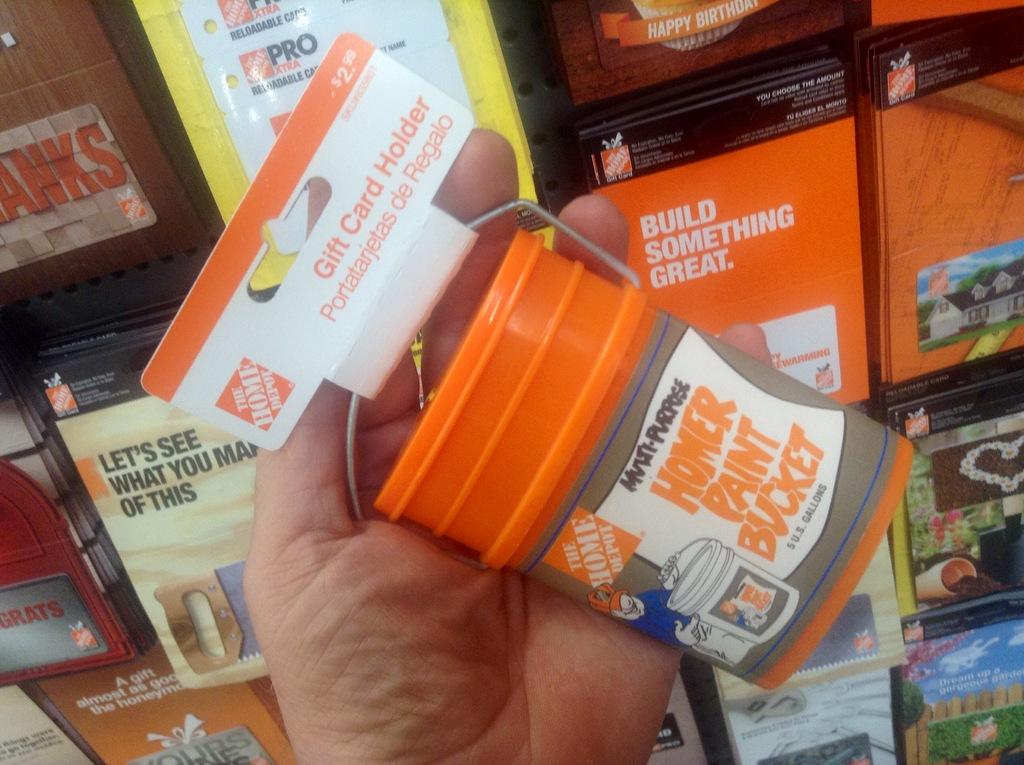Provide a one-sentence caption for the provided image. A hand holding a Home Depot gift card holder shaped like a Homer paint bucket. 